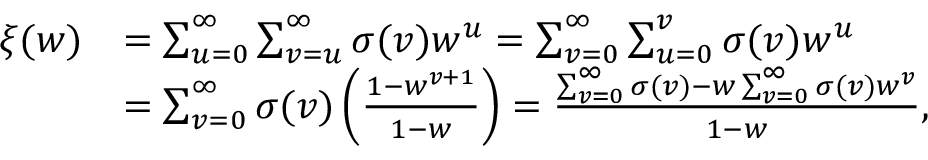Convert formula to latex. <formula><loc_0><loc_0><loc_500><loc_500>\begin{array} { r l } { \xi ( w ) } & { = \sum _ { u = 0 } ^ { \infty } \sum _ { v = u } ^ { \infty } \sigma ( v ) w ^ { u } = \sum _ { v = 0 } ^ { \infty } \sum _ { u = 0 } ^ { v } \sigma ( v ) w ^ { u } } \\ & { = \sum _ { v = 0 } ^ { \infty } \sigma ( v ) \left ( \frac { 1 - w ^ { v + 1 } } { 1 - w } \right ) = \frac { \sum _ { v = 0 } ^ { \infty } \sigma ( v ) - w \sum _ { v = 0 } ^ { \infty } \sigma ( v ) w ^ { v } } { 1 - w } , } \end{array}</formula> 